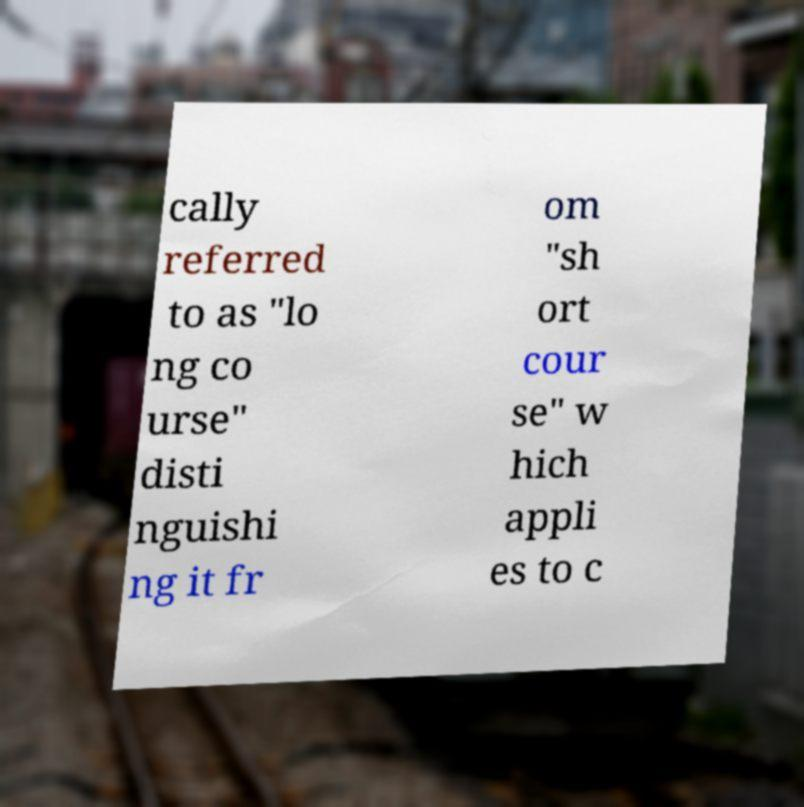For documentation purposes, I need the text within this image transcribed. Could you provide that? cally referred to as "lo ng co urse" disti nguishi ng it fr om "sh ort cour se" w hich appli es to c 